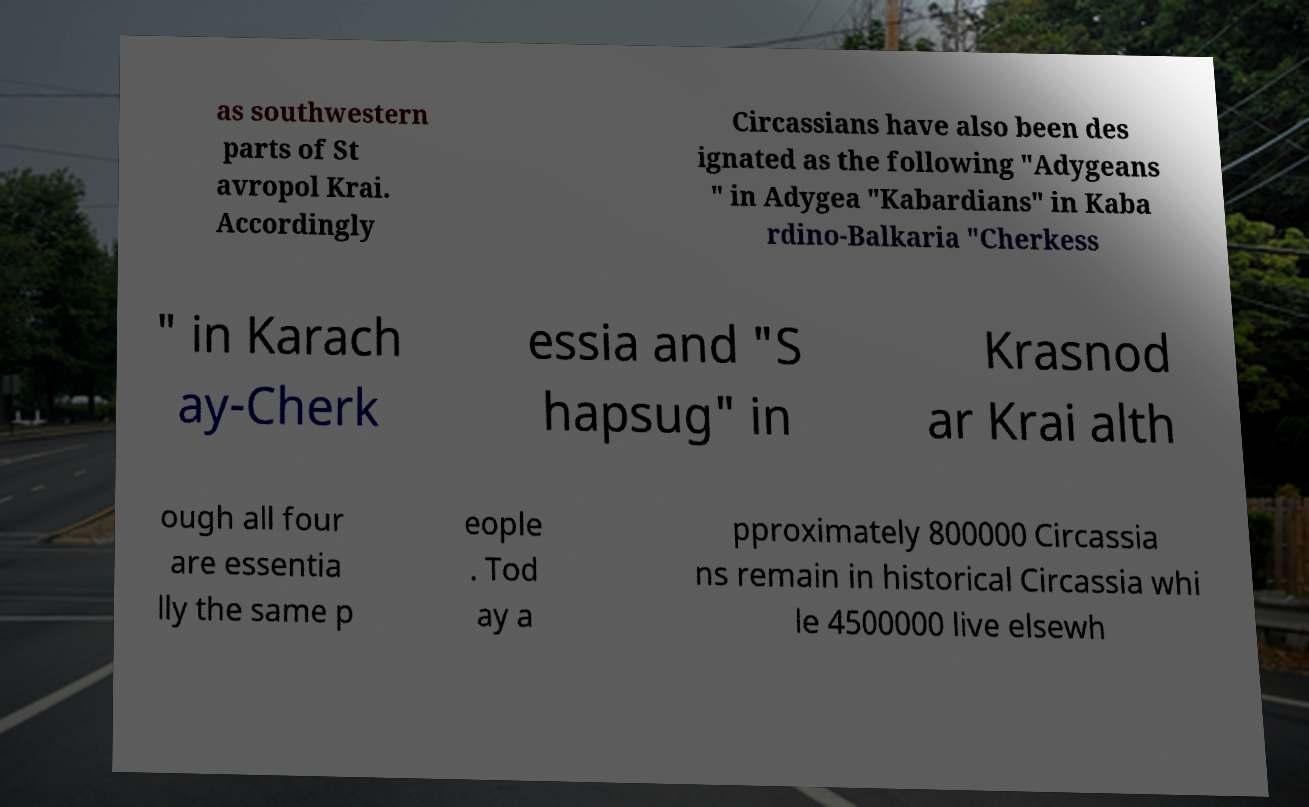Could you assist in decoding the text presented in this image and type it out clearly? as southwestern parts of St avropol Krai. Accordingly Circassians have also been des ignated as the following "Adygeans " in Adygea "Kabardians" in Kaba rdino-Balkaria "Cherkess " in Karach ay-Cherk essia and "S hapsug" in Krasnod ar Krai alth ough all four are essentia lly the same p eople . Tod ay a pproximately 800000 Circassia ns remain in historical Circassia whi le 4500000 live elsewh 